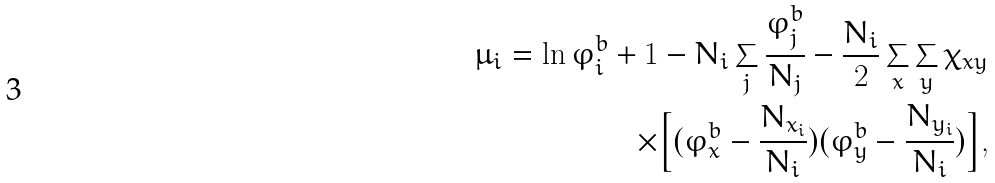Convert formula to latex. <formula><loc_0><loc_0><loc_500><loc_500>\mu _ { i } = \ln \varphi _ { i } ^ { b } + 1 - N _ { i } \sum _ { j } \frac { \varphi _ { j } ^ { b } } { N _ { j } } - \frac { N _ { i } } { 2 } \sum _ { x } \sum _ { y } \chi _ { x y } \\ \times \Big { [ } ( \varphi _ { x } ^ { b } - \frac { N _ { x _ { i } } } { N _ { i } } ) ( \varphi _ { y } ^ { b } - \frac { N _ { y _ { i } } } { N _ { i } } ) \Big { ] } ,</formula> 